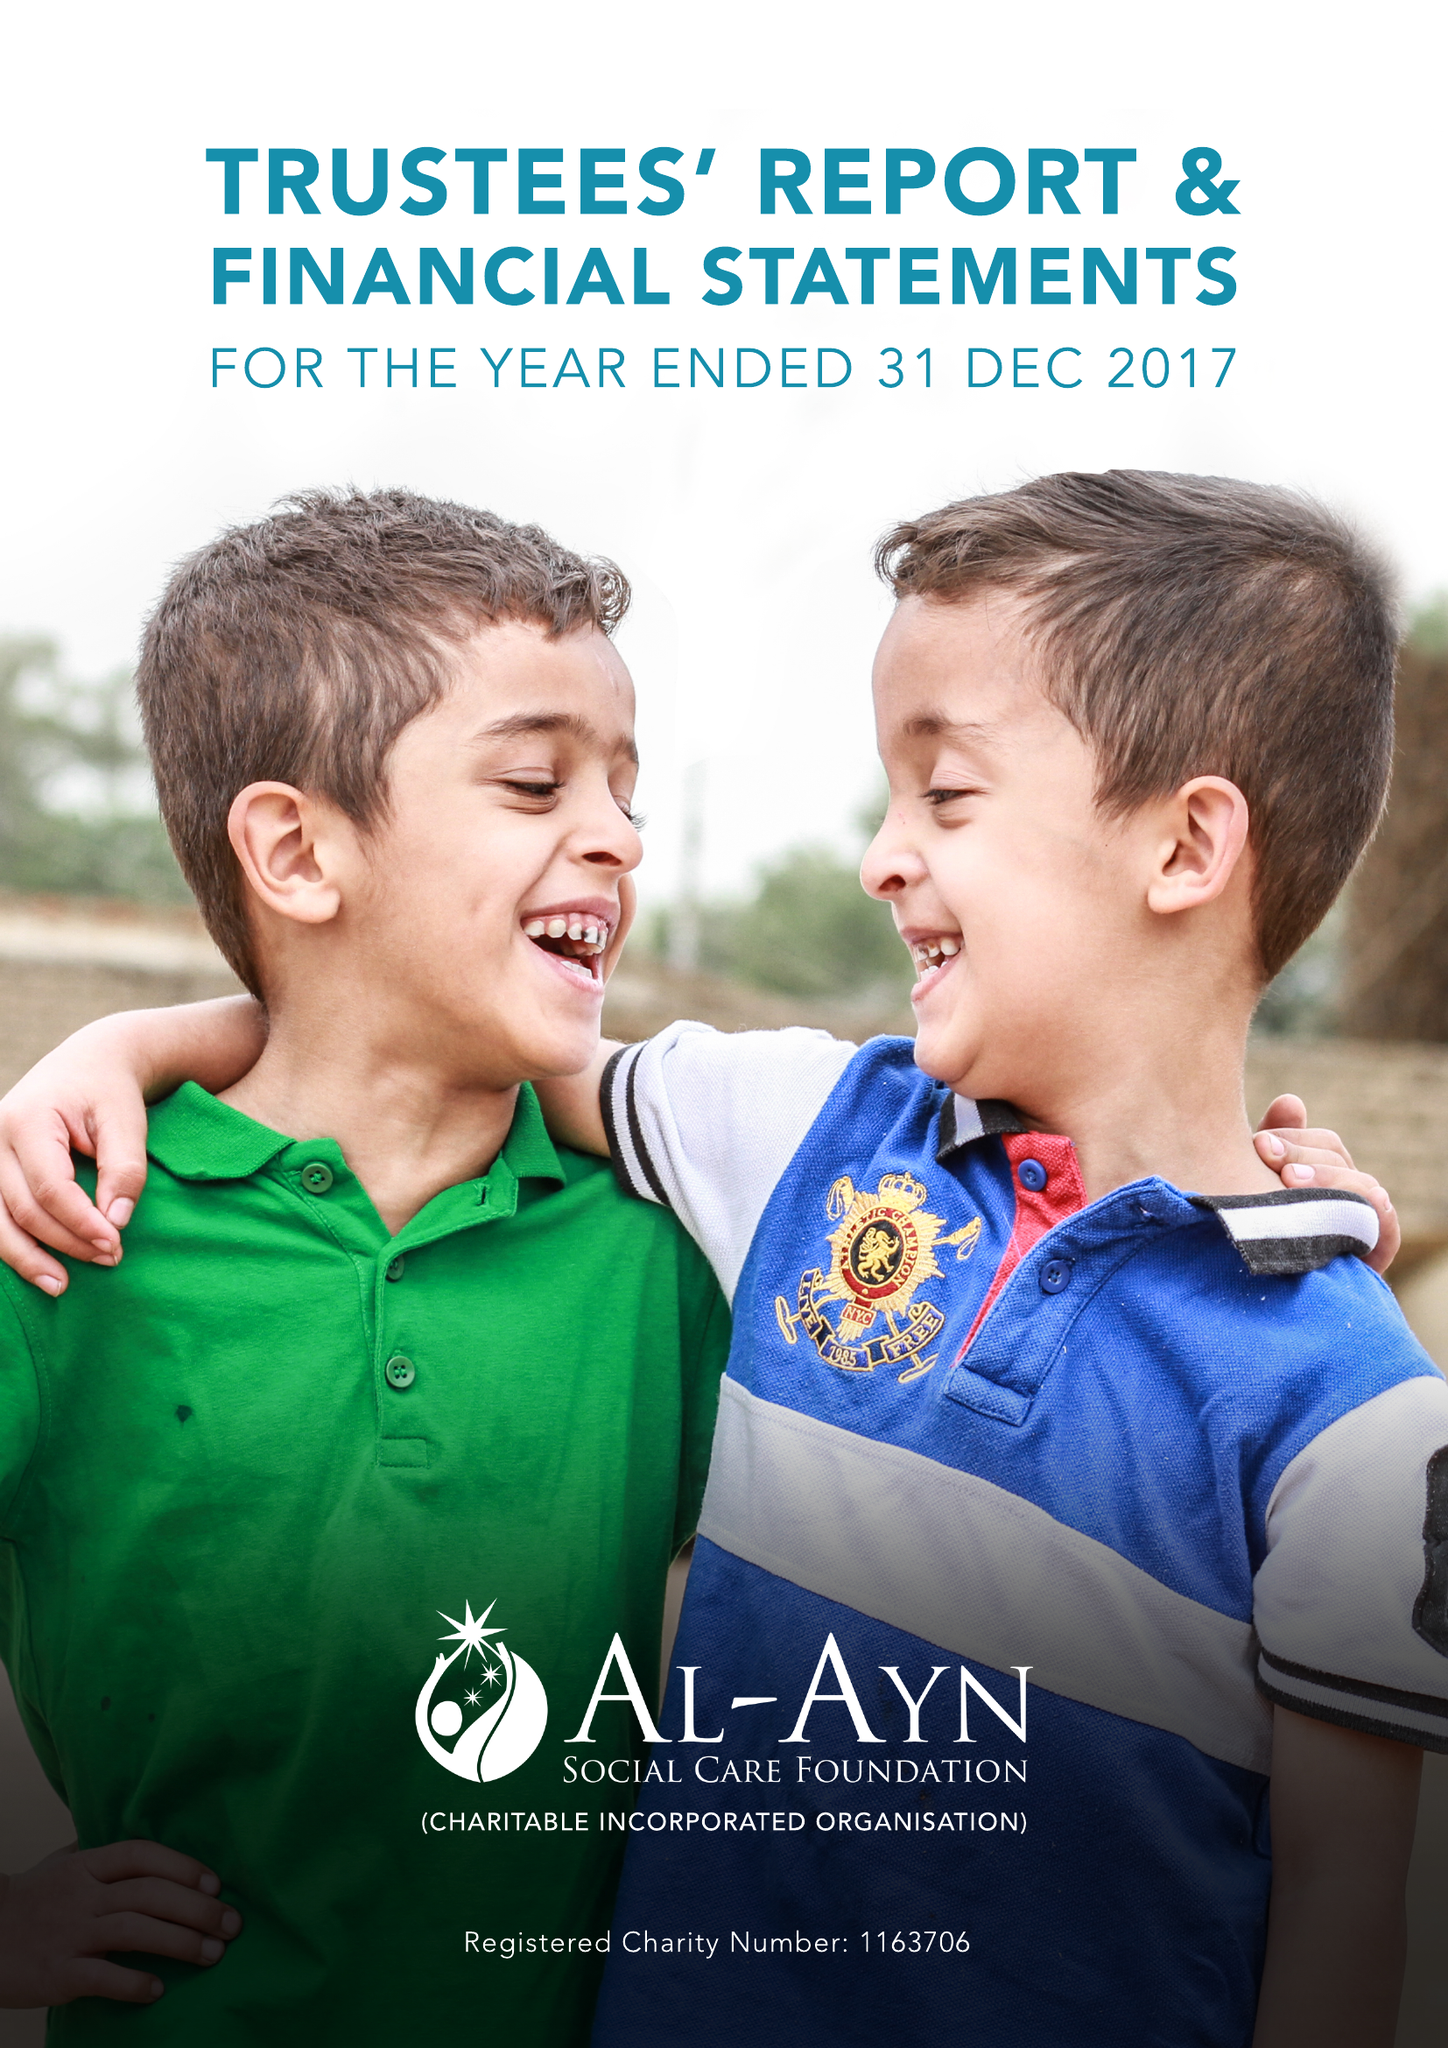What is the value for the charity_number?
Answer the question using a single word or phrase. 1163706 